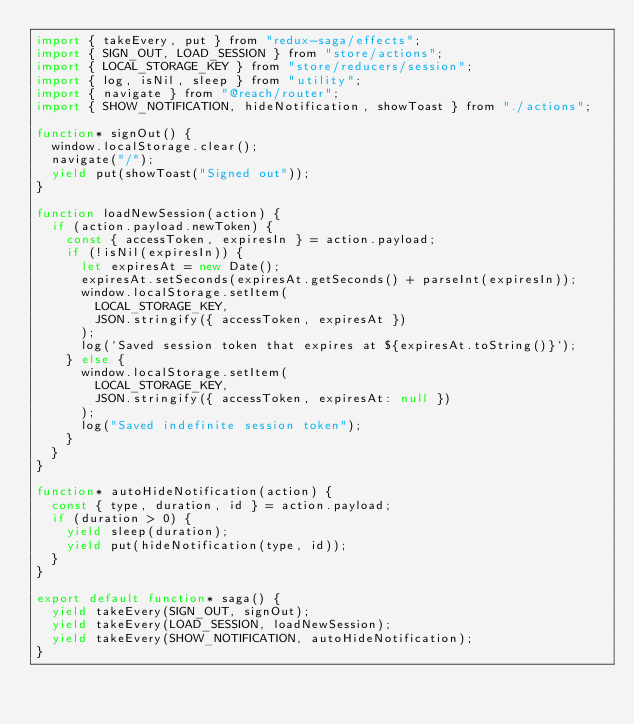Convert code to text. <code><loc_0><loc_0><loc_500><loc_500><_JavaScript_>import { takeEvery, put } from "redux-saga/effects";
import { SIGN_OUT, LOAD_SESSION } from "store/actions";
import { LOCAL_STORAGE_KEY } from "store/reducers/session";
import { log, isNil, sleep } from "utility";
import { navigate } from "@reach/router";
import { SHOW_NOTIFICATION, hideNotification, showToast } from "./actions";

function* signOut() {
  window.localStorage.clear();
  navigate("/");
  yield put(showToast("Signed out"));
}

function loadNewSession(action) {
  if (action.payload.newToken) {
    const { accessToken, expiresIn } = action.payload;
    if (!isNil(expiresIn)) {
      let expiresAt = new Date();
      expiresAt.setSeconds(expiresAt.getSeconds() + parseInt(expiresIn));
      window.localStorage.setItem(
        LOCAL_STORAGE_KEY,
        JSON.stringify({ accessToken, expiresAt })
      );
      log(`Saved session token that expires at ${expiresAt.toString()}`);
    } else {
      window.localStorage.setItem(
        LOCAL_STORAGE_KEY,
        JSON.stringify({ accessToken, expiresAt: null })
      );
      log("Saved indefinite session token");
    }
  }
}

function* autoHideNotification(action) {
  const { type, duration, id } = action.payload;
  if (duration > 0) {
    yield sleep(duration);
    yield put(hideNotification(type, id));
  }
}

export default function* saga() {
  yield takeEvery(SIGN_OUT, signOut);
  yield takeEvery(LOAD_SESSION, loadNewSession);
  yield takeEvery(SHOW_NOTIFICATION, autoHideNotification);
}
</code> 